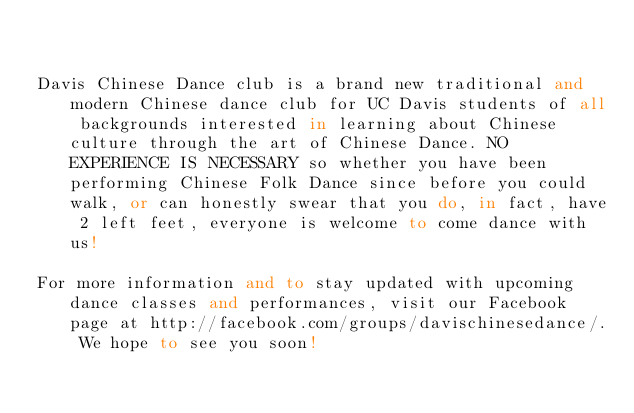<code> <loc_0><loc_0><loc_500><loc_500><_FORTRAN_>

Davis Chinese Dance club is a brand new traditional and modern Chinese dance club for UC Davis students of all backgrounds interested in learning about Chinese culture through the art of Chinese Dance. NO EXPERIENCE IS NECESSARY so whether you have been performing Chinese Folk Dance since before you could walk, or can honestly swear that you do, in fact, have 2 left feet, everyone is welcome to come dance with us!

For more information and to stay updated with upcoming dance classes and performances, visit our Facebook page at http://facebook.com/groups/davischinesedance/. We hope to see you soon!


</code> 